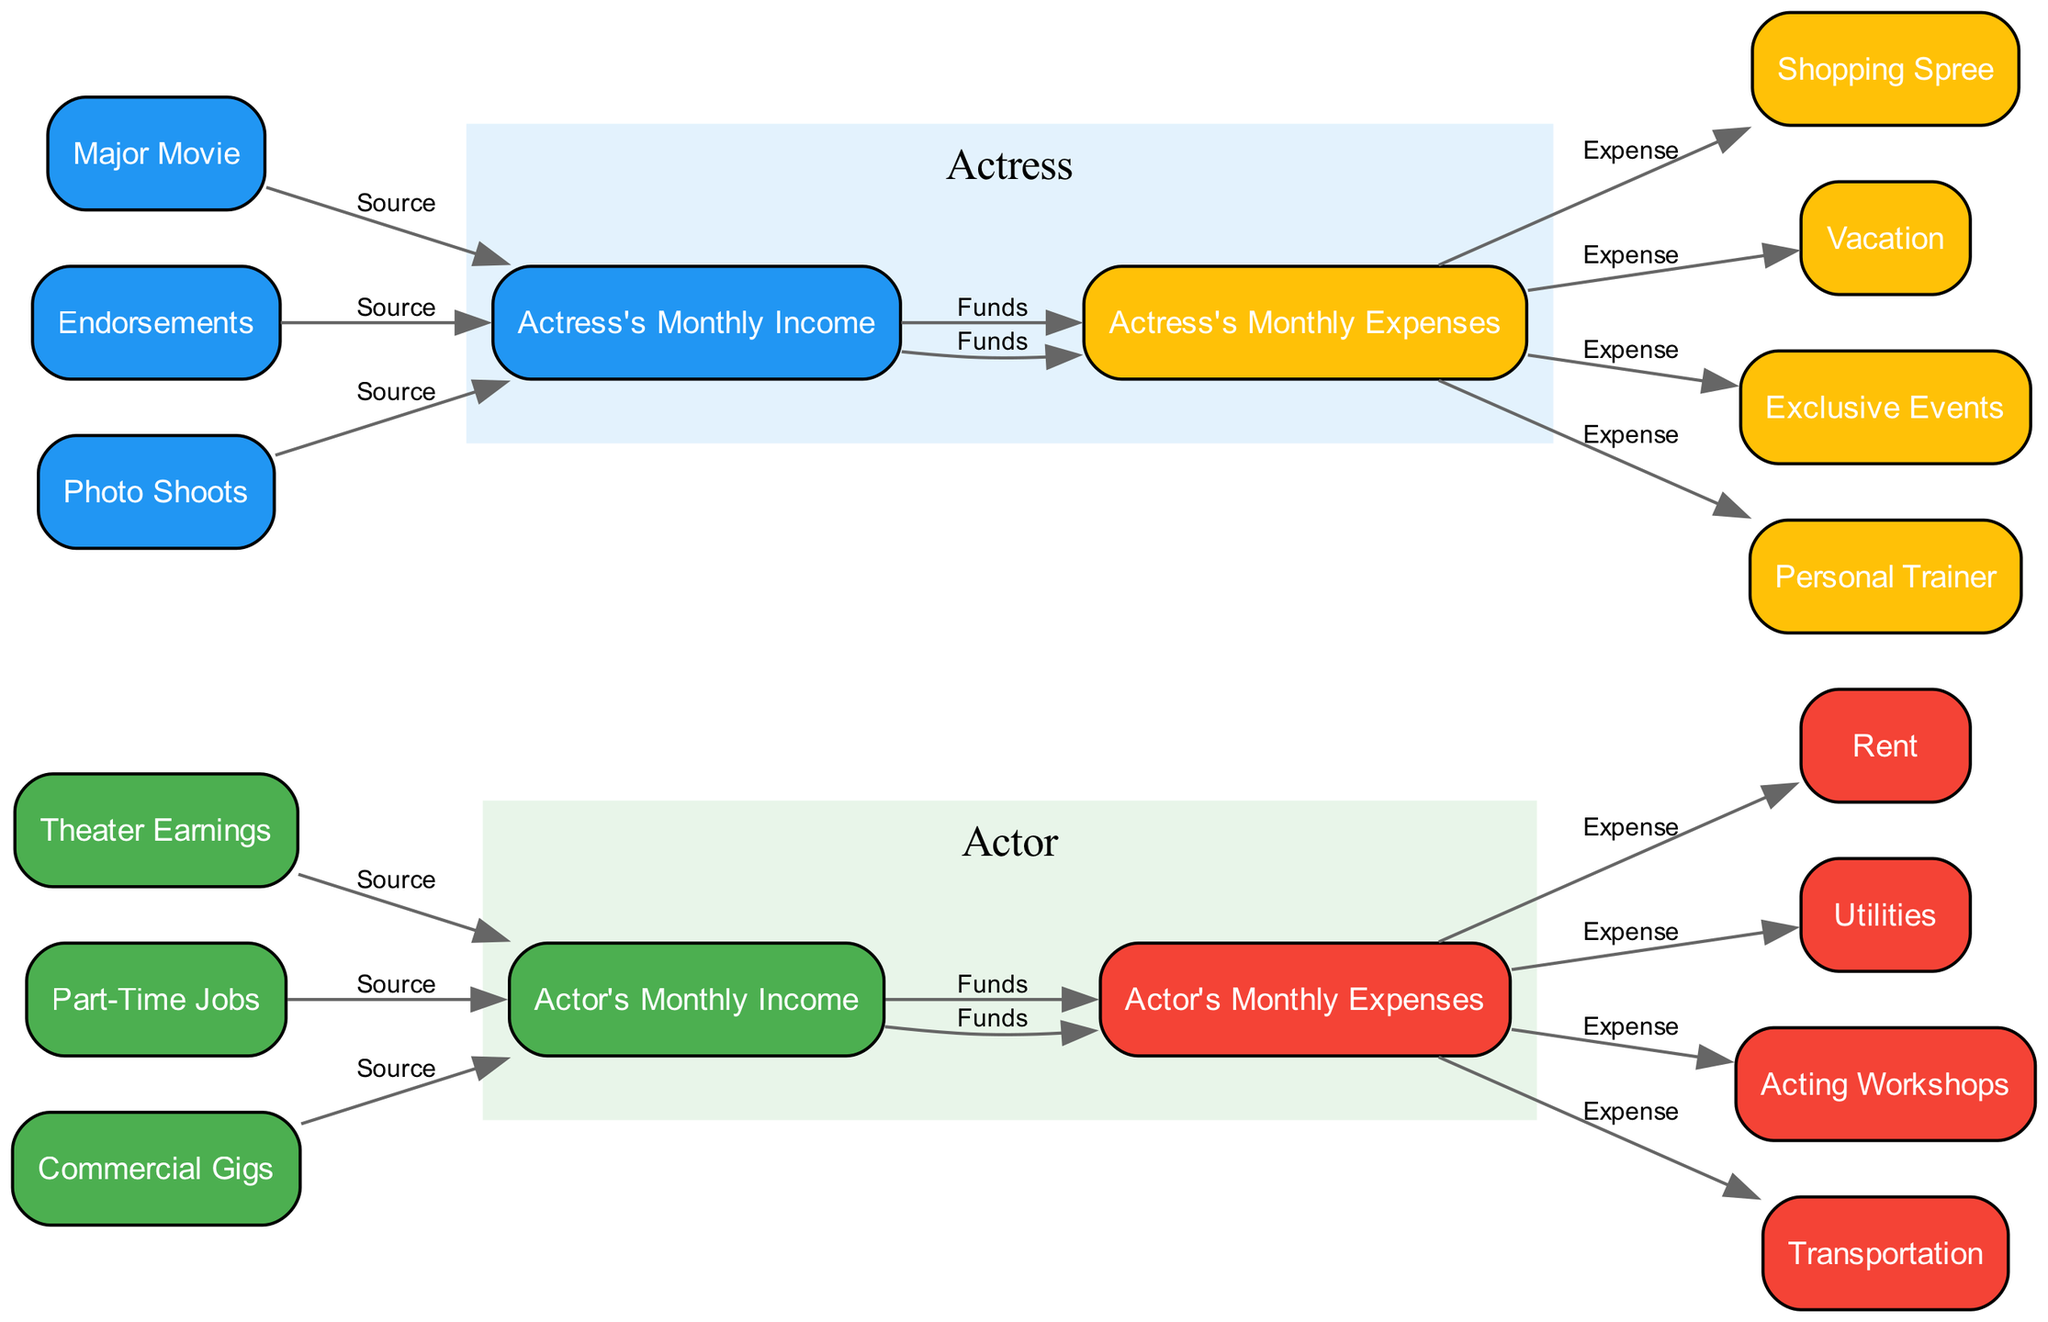What are the main sources of the actor's income? The main sources of the actor's income are represented by the nodes connected to "Actor's Monthly Income." These are "Theater Earnings," "Part-Time Jobs," and "Commercial Gigs."
Answer: Theater Earnings, Part-Time Jobs, Commercial Gigs How many edges are there in the diagram? Counting the edges in the diagram, we have connections for sources of income, flows of funds to expenses, and different expense categories. In total, there are 11 edges.
Answer: 11 What color represents the actress's expenses? The color representing the actress's expenses is shown in the node labeled "Actress's Monthly Expenses." That color is yellow.
Answer: Yellow Which node connects to the "Actor's Monthly Expenses" to represent rent? The node that connects to "Actor's Monthly Expenses" representing rent is "Rent." This is shown as an expense flowing out from the actor's expenses.
Answer: Rent Which income source contributes to the actress's income? The income sources contributing to the actress's income include "Major Movie," "Endorsements," and "Photo Shoots." They are depicted as flowing into the "Actress's Monthly Income" node.
Answer: Major Movie, Endorsements, Photo Shoots What is the relationship between "actress_expenses" and "shopping_spree"? The relationship is represented by an edge labeled "Expense." This indicates that "Shopping Spree" is one of the expenses associated with "Actress's Monthly Expenses."
Answer: Expense Which two categories of expenses are shown for the actor? The categories of expenses shown for the actor are fixed costs like rent and utilities, and variable costs like acting workshops and transportation. They flow from "Actor's Monthly Expenses."
Answer: Fixed and Variable Costs What is the most prominent color used for the actor's income? The most prominent color used for the actor's income is green, which is shown in the node labeled "Actor's Monthly Income."
Answer: Green 